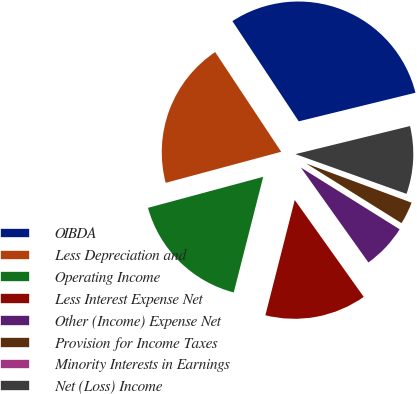Convert chart to OTSL. <chart><loc_0><loc_0><loc_500><loc_500><pie_chart><fcel>OIBDA<fcel>Less Depreciation and<fcel>Operating Income<fcel>Less Interest Expense Net<fcel>Other (Income) Expense Net<fcel>Provision for Income Taxes<fcel>Minority Interests in Earnings<fcel>Net (Loss) Income<nl><fcel>30.49%<fcel>19.88%<fcel>16.85%<fcel>13.82%<fcel>6.26%<fcel>3.23%<fcel>0.2%<fcel>9.29%<nl></chart> 